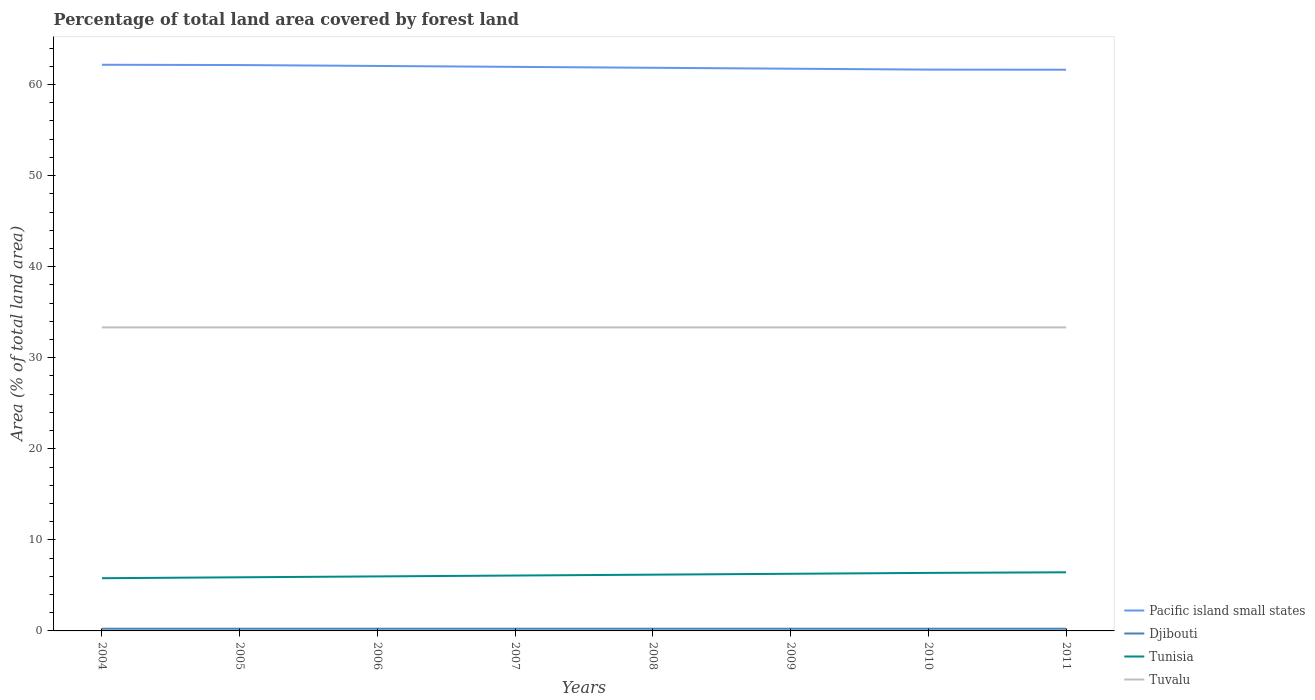How many different coloured lines are there?
Provide a succinct answer. 4. Does the line corresponding to Tuvalu intersect with the line corresponding to Tunisia?
Provide a short and direct response. No. Across all years, what is the maximum percentage of forest land in Tuvalu?
Offer a very short reply. 33.33. In which year was the percentage of forest land in Djibouti maximum?
Keep it short and to the point. 2004. What is the total percentage of forest land in Tunisia in the graph?
Keep it short and to the point. -0.1. What is the difference between the highest and the second highest percentage of forest land in Pacific island small states?
Give a very brief answer. 0.54. What is the difference between the highest and the lowest percentage of forest land in Pacific island small states?
Ensure brevity in your answer.  4. How many lines are there?
Your response must be concise. 4. How many years are there in the graph?
Make the answer very short. 8. Where does the legend appear in the graph?
Offer a very short reply. Bottom right. How many legend labels are there?
Provide a succinct answer. 4. How are the legend labels stacked?
Your answer should be compact. Vertical. What is the title of the graph?
Your response must be concise. Percentage of total land area covered by forest land. Does "East Asia (developing only)" appear as one of the legend labels in the graph?
Provide a short and direct response. No. What is the label or title of the X-axis?
Give a very brief answer. Years. What is the label or title of the Y-axis?
Your response must be concise. Area (% of total land area). What is the Area (% of total land area) in Pacific island small states in 2004?
Offer a terse response. 62.17. What is the Area (% of total land area) of Djibouti in 2004?
Your answer should be compact. 0.24. What is the Area (% of total land area) of Tunisia in 2004?
Ensure brevity in your answer.  5.79. What is the Area (% of total land area) in Tuvalu in 2004?
Offer a very short reply. 33.33. What is the Area (% of total land area) in Pacific island small states in 2005?
Offer a terse response. 62.14. What is the Area (% of total land area) of Djibouti in 2005?
Your answer should be compact. 0.24. What is the Area (% of total land area) of Tunisia in 2005?
Ensure brevity in your answer.  5.89. What is the Area (% of total land area) of Tuvalu in 2005?
Keep it short and to the point. 33.33. What is the Area (% of total land area) of Pacific island small states in 2006?
Your answer should be compact. 62.04. What is the Area (% of total land area) in Djibouti in 2006?
Offer a very short reply. 0.24. What is the Area (% of total land area) in Tunisia in 2006?
Offer a terse response. 5.99. What is the Area (% of total land area) of Tuvalu in 2006?
Keep it short and to the point. 33.33. What is the Area (% of total land area) in Pacific island small states in 2007?
Your answer should be very brief. 61.94. What is the Area (% of total land area) in Djibouti in 2007?
Give a very brief answer. 0.24. What is the Area (% of total land area) of Tunisia in 2007?
Provide a short and direct response. 6.08. What is the Area (% of total land area) in Tuvalu in 2007?
Provide a short and direct response. 33.33. What is the Area (% of total land area) in Pacific island small states in 2008?
Give a very brief answer. 61.84. What is the Area (% of total land area) of Djibouti in 2008?
Provide a short and direct response. 0.24. What is the Area (% of total land area) in Tunisia in 2008?
Your response must be concise. 6.18. What is the Area (% of total land area) in Tuvalu in 2008?
Your response must be concise. 33.33. What is the Area (% of total land area) in Pacific island small states in 2009?
Keep it short and to the point. 61.74. What is the Area (% of total land area) in Djibouti in 2009?
Keep it short and to the point. 0.24. What is the Area (% of total land area) of Tunisia in 2009?
Provide a short and direct response. 6.28. What is the Area (% of total land area) of Tuvalu in 2009?
Your answer should be very brief. 33.33. What is the Area (% of total land area) in Pacific island small states in 2010?
Provide a succinct answer. 61.64. What is the Area (% of total land area) of Djibouti in 2010?
Your response must be concise. 0.24. What is the Area (% of total land area) of Tunisia in 2010?
Keep it short and to the point. 6.37. What is the Area (% of total land area) of Tuvalu in 2010?
Offer a very short reply. 33.33. What is the Area (% of total land area) of Pacific island small states in 2011?
Your answer should be very brief. 61.63. What is the Area (% of total land area) of Djibouti in 2011?
Provide a succinct answer. 0.24. What is the Area (% of total land area) in Tunisia in 2011?
Provide a succinct answer. 6.44. What is the Area (% of total land area) of Tuvalu in 2011?
Your answer should be compact. 33.33. Across all years, what is the maximum Area (% of total land area) of Pacific island small states?
Provide a succinct answer. 62.17. Across all years, what is the maximum Area (% of total land area) in Djibouti?
Your answer should be compact. 0.24. Across all years, what is the maximum Area (% of total land area) of Tunisia?
Your answer should be very brief. 6.44. Across all years, what is the maximum Area (% of total land area) of Tuvalu?
Keep it short and to the point. 33.33. Across all years, what is the minimum Area (% of total land area) in Pacific island small states?
Offer a terse response. 61.63. Across all years, what is the minimum Area (% of total land area) of Djibouti?
Your response must be concise. 0.24. Across all years, what is the minimum Area (% of total land area) of Tunisia?
Offer a very short reply. 5.79. Across all years, what is the minimum Area (% of total land area) of Tuvalu?
Your answer should be very brief. 33.33. What is the total Area (% of total land area) of Pacific island small states in the graph?
Your response must be concise. 495.15. What is the total Area (% of total land area) in Djibouti in the graph?
Your answer should be very brief. 1.93. What is the total Area (% of total land area) in Tunisia in the graph?
Keep it short and to the point. 49.01. What is the total Area (% of total land area) of Tuvalu in the graph?
Your answer should be very brief. 266.67. What is the difference between the Area (% of total land area) in Pacific island small states in 2004 and that in 2005?
Ensure brevity in your answer.  0.03. What is the difference between the Area (% of total land area) of Tunisia in 2004 and that in 2005?
Your response must be concise. -0.1. What is the difference between the Area (% of total land area) in Tuvalu in 2004 and that in 2005?
Provide a short and direct response. 0. What is the difference between the Area (% of total land area) of Pacific island small states in 2004 and that in 2006?
Give a very brief answer. 0.13. What is the difference between the Area (% of total land area) of Djibouti in 2004 and that in 2006?
Keep it short and to the point. 0. What is the difference between the Area (% of total land area) of Tunisia in 2004 and that in 2006?
Your answer should be very brief. -0.2. What is the difference between the Area (% of total land area) of Tuvalu in 2004 and that in 2006?
Give a very brief answer. 0. What is the difference between the Area (% of total land area) of Pacific island small states in 2004 and that in 2007?
Your answer should be very brief. 0.23. What is the difference between the Area (% of total land area) in Tunisia in 2004 and that in 2007?
Offer a terse response. -0.29. What is the difference between the Area (% of total land area) of Pacific island small states in 2004 and that in 2008?
Keep it short and to the point. 0.33. What is the difference between the Area (% of total land area) of Tunisia in 2004 and that in 2008?
Your response must be concise. -0.39. What is the difference between the Area (% of total land area) of Pacific island small states in 2004 and that in 2009?
Provide a short and direct response. 0.43. What is the difference between the Area (% of total land area) of Tunisia in 2004 and that in 2009?
Give a very brief answer. -0.49. What is the difference between the Area (% of total land area) in Tuvalu in 2004 and that in 2009?
Your response must be concise. 0. What is the difference between the Area (% of total land area) in Pacific island small states in 2004 and that in 2010?
Your answer should be compact. 0.53. What is the difference between the Area (% of total land area) of Djibouti in 2004 and that in 2010?
Offer a very short reply. 0. What is the difference between the Area (% of total land area) of Tunisia in 2004 and that in 2010?
Ensure brevity in your answer.  -0.58. What is the difference between the Area (% of total land area) in Pacific island small states in 2004 and that in 2011?
Make the answer very short. 0.54. What is the difference between the Area (% of total land area) in Djibouti in 2004 and that in 2011?
Your answer should be compact. 0. What is the difference between the Area (% of total land area) in Tunisia in 2004 and that in 2011?
Your answer should be compact. -0.65. What is the difference between the Area (% of total land area) of Tuvalu in 2004 and that in 2011?
Provide a short and direct response. 0. What is the difference between the Area (% of total land area) of Pacific island small states in 2005 and that in 2006?
Offer a very short reply. 0.1. What is the difference between the Area (% of total land area) in Djibouti in 2005 and that in 2006?
Ensure brevity in your answer.  0. What is the difference between the Area (% of total land area) of Tunisia in 2005 and that in 2006?
Make the answer very short. -0.1. What is the difference between the Area (% of total land area) in Pacific island small states in 2005 and that in 2007?
Your answer should be compact. 0.2. What is the difference between the Area (% of total land area) of Djibouti in 2005 and that in 2007?
Your answer should be very brief. 0. What is the difference between the Area (% of total land area) of Tunisia in 2005 and that in 2007?
Give a very brief answer. -0.19. What is the difference between the Area (% of total land area) of Tuvalu in 2005 and that in 2007?
Offer a very short reply. 0. What is the difference between the Area (% of total land area) in Pacific island small states in 2005 and that in 2008?
Make the answer very short. 0.3. What is the difference between the Area (% of total land area) in Djibouti in 2005 and that in 2008?
Offer a terse response. 0. What is the difference between the Area (% of total land area) in Tunisia in 2005 and that in 2008?
Give a very brief answer. -0.29. What is the difference between the Area (% of total land area) in Tuvalu in 2005 and that in 2008?
Your answer should be very brief. 0. What is the difference between the Area (% of total land area) in Pacific island small states in 2005 and that in 2009?
Your answer should be very brief. 0.4. What is the difference between the Area (% of total land area) of Djibouti in 2005 and that in 2009?
Offer a terse response. 0. What is the difference between the Area (% of total land area) in Tunisia in 2005 and that in 2009?
Give a very brief answer. -0.39. What is the difference between the Area (% of total land area) in Pacific island small states in 2005 and that in 2010?
Provide a short and direct response. 0.5. What is the difference between the Area (% of total land area) of Tunisia in 2005 and that in 2010?
Keep it short and to the point. -0.48. What is the difference between the Area (% of total land area) in Tuvalu in 2005 and that in 2010?
Your response must be concise. 0. What is the difference between the Area (% of total land area) of Pacific island small states in 2005 and that in 2011?
Your answer should be compact. 0.51. What is the difference between the Area (% of total land area) in Tunisia in 2005 and that in 2011?
Offer a very short reply. -0.55. What is the difference between the Area (% of total land area) of Pacific island small states in 2006 and that in 2007?
Provide a short and direct response. 0.1. What is the difference between the Area (% of total land area) in Tunisia in 2006 and that in 2007?
Keep it short and to the point. -0.1. What is the difference between the Area (% of total land area) of Pacific island small states in 2006 and that in 2008?
Keep it short and to the point. 0.2. What is the difference between the Area (% of total land area) in Djibouti in 2006 and that in 2008?
Provide a short and direct response. 0. What is the difference between the Area (% of total land area) in Tunisia in 2006 and that in 2008?
Make the answer very short. -0.19. What is the difference between the Area (% of total land area) of Pacific island small states in 2006 and that in 2009?
Provide a short and direct response. 0.3. What is the difference between the Area (% of total land area) of Djibouti in 2006 and that in 2009?
Offer a very short reply. 0. What is the difference between the Area (% of total land area) of Tunisia in 2006 and that in 2009?
Make the answer very short. -0.29. What is the difference between the Area (% of total land area) of Tuvalu in 2006 and that in 2009?
Provide a short and direct response. 0. What is the difference between the Area (% of total land area) of Pacific island small states in 2006 and that in 2010?
Ensure brevity in your answer.  0.4. What is the difference between the Area (% of total land area) in Djibouti in 2006 and that in 2010?
Offer a terse response. 0. What is the difference between the Area (% of total land area) in Tunisia in 2006 and that in 2010?
Offer a very short reply. -0.39. What is the difference between the Area (% of total land area) in Pacific island small states in 2006 and that in 2011?
Offer a very short reply. 0.41. What is the difference between the Area (% of total land area) in Djibouti in 2006 and that in 2011?
Provide a short and direct response. 0. What is the difference between the Area (% of total land area) in Tunisia in 2006 and that in 2011?
Provide a short and direct response. -0.45. What is the difference between the Area (% of total land area) in Pacific island small states in 2007 and that in 2008?
Provide a short and direct response. 0.1. What is the difference between the Area (% of total land area) of Djibouti in 2007 and that in 2008?
Make the answer very short. 0. What is the difference between the Area (% of total land area) of Tunisia in 2007 and that in 2008?
Provide a short and direct response. -0.1. What is the difference between the Area (% of total land area) of Tuvalu in 2007 and that in 2008?
Ensure brevity in your answer.  0. What is the difference between the Area (% of total land area) in Pacific island small states in 2007 and that in 2009?
Provide a succinct answer. 0.2. What is the difference between the Area (% of total land area) of Tunisia in 2007 and that in 2009?
Provide a short and direct response. -0.19. What is the difference between the Area (% of total land area) in Tuvalu in 2007 and that in 2009?
Your response must be concise. 0. What is the difference between the Area (% of total land area) of Pacific island small states in 2007 and that in 2010?
Keep it short and to the point. 0.3. What is the difference between the Area (% of total land area) of Djibouti in 2007 and that in 2010?
Your answer should be very brief. 0. What is the difference between the Area (% of total land area) of Tunisia in 2007 and that in 2010?
Your answer should be very brief. -0.29. What is the difference between the Area (% of total land area) of Pacific island small states in 2007 and that in 2011?
Provide a short and direct response. 0.31. What is the difference between the Area (% of total land area) of Djibouti in 2007 and that in 2011?
Make the answer very short. 0. What is the difference between the Area (% of total land area) in Tunisia in 2007 and that in 2011?
Provide a short and direct response. -0.36. What is the difference between the Area (% of total land area) in Pacific island small states in 2008 and that in 2009?
Give a very brief answer. 0.1. What is the difference between the Area (% of total land area) of Tunisia in 2008 and that in 2009?
Give a very brief answer. -0.1. What is the difference between the Area (% of total land area) in Pacific island small states in 2008 and that in 2010?
Provide a succinct answer. 0.2. What is the difference between the Area (% of total land area) of Tunisia in 2008 and that in 2010?
Your answer should be compact. -0.19. What is the difference between the Area (% of total land area) in Pacific island small states in 2008 and that in 2011?
Give a very brief answer. 0.21. What is the difference between the Area (% of total land area) of Tunisia in 2008 and that in 2011?
Make the answer very short. -0.26. What is the difference between the Area (% of total land area) of Tuvalu in 2008 and that in 2011?
Offer a very short reply. 0. What is the difference between the Area (% of total land area) of Pacific island small states in 2009 and that in 2010?
Keep it short and to the point. 0.1. What is the difference between the Area (% of total land area) of Tunisia in 2009 and that in 2010?
Your answer should be compact. -0.1. What is the difference between the Area (% of total land area) in Tuvalu in 2009 and that in 2010?
Your response must be concise. 0. What is the difference between the Area (% of total land area) in Pacific island small states in 2009 and that in 2011?
Give a very brief answer. 0.11. What is the difference between the Area (% of total land area) in Tunisia in 2009 and that in 2011?
Your answer should be compact. -0.16. What is the difference between the Area (% of total land area) in Pacific island small states in 2010 and that in 2011?
Offer a terse response. 0.01. What is the difference between the Area (% of total land area) of Tunisia in 2010 and that in 2011?
Your answer should be very brief. -0.07. What is the difference between the Area (% of total land area) in Tuvalu in 2010 and that in 2011?
Your answer should be compact. 0. What is the difference between the Area (% of total land area) of Pacific island small states in 2004 and the Area (% of total land area) of Djibouti in 2005?
Provide a short and direct response. 61.93. What is the difference between the Area (% of total land area) in Pacific island small states in 2004 and the Area (% of total land area) in Tunisia in 2005?
Offer a terse response. 56.28. What is the difference between the Area (% of total land area) in Pacific island small states in 2004 and the Area (% of total land area) in Tuvalu in 2005?
Keep it short and to the point. 28.84. What is the difference between the Area (% of total land area) of Djibouti in 2004 and the Area (% of total land area) of Tunisia in 2005?
Keep it short and to the point. -5.65. What is the difference between the Area (% of total land area) of Djibouti in 2004 and the Area (% of total land area) of Tuvalu in 2005?
Offer a terse response. -33.09. What is the difference between the Area (% of total land area) of Tunisia in 2004 and the Area (% of total land area) of Tuvalu in 2005?
Offer a terse response. -27.54. What is the difference between the Area (% of total land area) in Pacific island small states in 2004 and the Area (% of total land area) in Djibouti in 2006?
Keep it short and to the point. 61.93. What is the difference between the Area (% of total land area) in Pacific island small states in 2004 and the Area (% of total land area) in Tunisia in 2006?
Your answer should be very brief. 56.19. What is the difference between the Area (% of total land area) of Pacific island small states in 2004 and the Area (% of total land area) of Tuvalu in 2006?
Your response must be concise. 28.84. What is the difference between the Area (% of total land area) in Djibouti in 2004 and the Area (% of total land area) in Tunisia in 2006?
Your answer should be compact. -5.74. What is the difference between the Area (% of total land area) of Djibouti in 2004 and the Area (% of total land area) of Tuvalu in 2006?
Provide a short and direct response. -33.09. What is the difference between the Area (% of total land area) of Tunisia in 2004 and the Area (% of total land area) of Tuvalu in 2006?
Your answer should be compact. -27.54. What is the difference between the Area (% of total land area) of Pacific island small states in 2004 and the Area (% of total land area) of Djibouti in 2007?
Provide a succinct answer. 61.93. What is the difference between the Area (% of total land area) in Pacific island small states in 2004 and the Area (% of total land area) in Tunisia in 2007?
Provide a succinct answer. 56.09. What is the difference between the Area (% of total land area) of Pacific island small states in 2004 and the Area (% of total land area) of Tuvalu in 2007?
Your answer should be very brief. 28.84. What is the difference between the Area (% of total land area) in Djibouti in 2004 and the Area (% of total land area) in Tunisia in 2007?
Offer a very short reply. -5.84. What is the difference between the Area (% of total land area) in Djibouti in 2004 and the Area (% of total land area) in Tuvalu in 2007?
Your answer should be very brief. -33.09. What is the difference between the Area (% of total land area) in Tunisia in 2004 and the Area (% of total land area) in Tuvalu in 2007?
Make the answer very short. -27.54. What is the difference between the Area (% of total land area) in Pacific island small states in 2004 and the Area (% of total land area) in Djibouti in 2008?
Give a very brief answer. 61.93. What is the difference between the Area (% of total land area) in Pacific island small states in 2004 and the Area (% of total land area) in Tunisia in 2008?
Provide a succinct answer. 55.99. What is the difference between the Area (% of total land area) in Pacific island small states in 2004 and the Area (% of total land area) in Tuvalu in 2008?
Give a very brief answer. 28.84. What is the difference between the Area (% of total land area) of Djibouti in 2004 and the Area (% of total land area) of Tunisia in 2008?
Keep it short and to the point. -5.94. What is the difference between the Area (% of total land area) in Djibouti in 2004 and the Area (% of total land area) in Tuvalu in 2008?
Offer a very short reply. -33.09. What is the difference between the Area (% of total land area) in Tunisia in 2004 and the Area (% of total land area) in Tuvalu in 2008?
Keep it short and to the point. -27.54. What is the difference between the Area (% of total land area) of Pacific island small states in 2004 and the Area (% of total land area) of Djibouti in 2009?
Ensure brevity in your answer.  61.93. What is the difference between the Area (% of total land area) in Pacific island small states in 2004 and the Area (% of total land area) in Tunisia in 2009?
Your answer should be very brief. 55.9. What is the difference between the Area (% of total land area) of Pacific island small states in 2004 and the Area (% of total land area) of Tuvalu in 2009?
Ensure brevity in your answer.  28.84. What is the difference between the Area (% of total land area) of Djibouti in 2004 and the Area (% of total land area) of Tunisia in 2009?
Offer a terse response. -6.03. What is the difference between the Area (% of total land area) in Djibouti in 2004 and the Area (% of total land area) in Tuvalu in 2009?
Give a very brief answer. -33.09. What is the difference between the Area (% of total land area) in Tunisia in 2004 and the Area (% of total land area) in Tuvalu in 2009?
Provide a short and direct response. -27.54. What is the difference between the Area (% of total land area) in Pacific island small states in 2004 and the Area (% of total land area) in Djibouti in 2010?
Offer a very short reply. 61.93. What is the difference between the Area (% of total land area) of Pacific island small states in 2004 and the Area (% of total land area) of Tunisia in 2010?
Give a very brief answer. 55.8. What is the difference between the Area (% of total land area) of Pacific island small states in 2004 and the Area (% of total land area) of Tuvalu in 2010?
Offer a terse response. 28.84. What is the difference between the Area (% of total land area) of Djibouti in 2004 and the Area (% of total land area) of Tunisia in 2010?
Your answer should be very brief. -6.13. What is the difference between the Area (% of total land area) of Djibouti in 2004 and the Area (% of total land area) of Tuvalu in 2010?
Ensure brevity in your answer.  -33.09. What is the difference between the Area (% of total land area) of Tunisia in 2004 and the Area (% of total land area) of Tuvalu in 2010?
Your answer should be compact. -27.54. What is the difference between the Area (% of total land area) in Pacific island small states in 2004 and the Area (% of total land area) in Djibouti in 2011?
Offer a very short reply. 61.93. What is the difference between the Area (% of total land area) in Pacific island small states in 2004 and the Area (% of total land area) in Tunisia in 2011?
Your response must be concise. 55.73. What is the difference between the Area (% of total land area) of Pacific island small states in 2004 and the Area (% of total land area) of Tuvalu in 2011?
Your answer should be very brief. 28.84. What is the difference between the Area (% of total land area) of Djibouti in 2004 and the Area (% of total land area) of Tunisia in 2011?
Offer a terse response. -6.2. What is the difference between the Area (% of total land area) of Djibouti in 2004 and the Area (% of total land area) of Tuvalu in 2011?
Ensure brevity in your answer.  -33.09. What is the difference between the Area (% of total land area) of Tunisia in 2004 and the Area (% of total land area) of Tuvalu in 2011?
Your answer should be compact. -27.54. What is the difference between the Area (% of total land area) of Pacific island small states in 2005 and the Area (% of total land area) of Djibouti in 2006?
Your answer should be compact. 61.9. What is the difference between the Area (% of total land area) of Pacific island small states in 2005 and the Area (% of total land area) of Tunisia in 2006?
Provide a short and direct response. 56.16. What is the difference between the Area (% of total land area) of Pacific island small states in 2005 and the Area (% of total land area) of Tuvalu in 2006?
Ensure brevity in your answer.  28.81. What is the difference between the Area (% of total land area) of Djibouti in 2005 and the Area (% of total land area) of Tunisia in 2006?
Your answer should be compact. -5.74. What is the difference between the Area (% of total land area) of Djibouti in 2005 and the Area (% of total land area) of Tuvalu in 2006?
Offer a very short reply. -33.09. What is the difference between the Area (% of total land area) in Tunisia in 2005 and the Area (% of total land area) in Tuvalu in 2006?
Ensure brevity in your answer.  -27.44. What is the difference between the Area (% of total land area) of Pacific island small states in 2005 and the Area (% of total land area) of Djibouti in 2007?
Give a very brief answer. 61.9. What is the difference between the Area (% of total land area) in Pacific island small states in 2005 and the Area (% of total land area) in Tunisia in 2007?
Provide a succinct answer. 56.06. What is the difference between the Area (% of total land area) of Pacific island small states in 2005 and the Area (% of total land area) of Tuvalu in 2007?
Make the answer very short. 28.81. What is the difference between the Area (% of total land area) of Djibouti in 2005 and the Area (% of total land area) of Tunisia in 2007?
Your answer should be compact. -5.84. What is the difference between the Area (% of total land area) of Djibouti in 2005 and the Area (% of total land area) of Tuvalu in 2007?
Provide a succinct answer. -33.09. What is the difference between the Area (% of total land area) of Tunisia in 2005 and the Area (% of total land area) of Tuvalu in 2007?
Keep it short and to the point. -27.44. What is the difference between the Area (% of total land area) in Pacific island small states in 2005 and the Area (% of total land area) in Djibouti in 2008?
Provide a short and direct response. 61.9. What is the difference between the Area (% of total land area) in Pacific island small states in 2005 and the Area (% of total land area) in Tunisia in 2008?
Make the answer very short. 55.96. What is the difference between the Area (% of total land area) in Pacific island small states in 2005 and the Area (% of total land area) in Tuvalu in 2008?
Provide a short and direct response. 28.81. What is the difference between the Area (% of total land area) in Djibouti in 2005 and the Area (% of total land area) in Tunisia in 2008?
Make the answer very short. -5.94. What is the difference between the Area (% of total land area) of Djibouti in 2005 and the Area (% of total land area) of Tuvalu in 2008?
Your response must be concise. -33.09. What is the difference between the Area (% of total land area) in Tunisia in 2005 and the Area (% of total land area) in Tuvalu in 2008?
Keep it short and to the point. -27.44. What is the difference between the Area (% of total land area) of Pacific island small states in 2005 and the Area (% of total land area) of Djibouti in 2009?
Your answer should be very brief. 61.9. What is the difference between the Area (% of total land area) of Pacific island small states in 2005 and the Area (% of total land area) of Tunisia in 2009?
Provide a succinct answer. 55.87. What is the difference between the Area (% of total land area) in Pacific island small states in 2005 and the Area (% of total land area) in Tuvalu in 2009?
Your response must be concise. 28.81. What is the difference between the Area (% of total land area) of Djibouti in 2005 and the Area (% of total land area) of Tunisia in 2009?
Your answer should be very brief. -6.03. What is the difference between the Area (% of total land area) in Djibouti in 2005 and the Area (% of total land area) in Tuvalu in 2009?
Provide a short and direct response. -33.09. What is the difference between the Area (% of total land area) of Tunisia in 2005 and the Area (% of total land area) of Tuvalu in 2009?
Provide a short and direct response. -27.44. What is the difference between the Area (% of total land area) of Pacific island small states in 2005 and the Area (% of total land area) of Djibouti in 2010?
Offer a very short reply. 61.9. What is the difference between the Area (% of total land area) of Pacific island small states in 2005 and the Area (% of total land area) of Tunisia in 2010?
Provide a succinct answer. 55.77. What is the difference between the Area (% of total land area) in Pacific island small states in 2005 and the Area (% of total land area) in Tuvalu in 2010?
Your answer should be very brief. 28.81. What is the difference between the Area (% of total land area) of Djibouti in 2005 and the Area (% of total land area) of Tunisia in 2010?
Offer a very short reply. -6.13. What is the difference between the Area (% of total land area) in Djibouti in 2005 and the Area (% of total land area) in Tuvalu in 2010?
Ensure brevity in your answer.  -33.09. What is the difference between the Area (% of total land area) in Tunisia in 2005 and the Area (% of total land area) in Tuvalu in 2010?
Provide a short and direct response. -27.44. What is the difference between the Area (% of total land area) in Pacific island small states in 2005 and the Area (% of total land area) in Djibouti in 2011?
Your answer should be compact. 61.9. What is the difference between the Area (% of total land area) in Pacific island small states in 2005 and the Area (% of total land area) in Tunisia in 2011?
Provide a short and direct response. 55.71. What is the difference between the Area (% of total land area) of Pacific island small states in 2005 and the Area (% of total land area) of Tuvalu in 2011?
Give a very brief answer. 28.81. What is the difference between the Area (% of total land area) in Djibouti in 2005 and the Area (% of total land area) in Tunisia in 2011?
Your answer should be very brief. -6.2. What is the difference between the Area (% of total land area) in Djibouti in 2005 and the Area (% of total land area) in Tuvalu in 2011?
Make the answer very short. -33.09. What is the difference between the Area (% of total land area) in Tunisia in 2005 and the Area (% of total land area) in Tuvalu in 2011?
Your answer should be very brief. -27.44. What is the difference between the Area (% of total land area) of Pacific island small states in 2006 and the Area (% of total land area) of Djibouti in 2007?
Offer a very short reply. 61.8. What is the difference between the Area (% of total land area) in Pacific island small states in 2006 and the Area (% of total land area) in Tunisia in 2007?
Offer a very short reply. 55.96. What is the difference between the Area (% of total land area) of Pacific island small states in 2006 and the Area (% of total land area) of Tuvalu in 2007?
Keep it short and to the point. 28.71. What is the difference between the Area (% of total land area) of Djibouti in 2006 and the Area (% of total land area) of Tunisia in 2007?
Keep it short and to the point. -5.84. What is the difference between the Area (% of total land area) in Djibouti in 2006 and the Area (% of total land area) in Tuvalu in 2007?
Provide a succinct answer. -33.09. What is the difference between the Area (% of total land area) of Tunisia in 2006 and the Area (% of total land area) of Tuvalu in 2007?
Keep it short and to the point. -27.35. What is the difference between the Area (% of total land area) of Pacific island small states in 2006 and the Area (% of total land area) of Djibouti in 2008?
Provide a succinct answer. 61.8. What is the difference between the Area (% of total land area) of Pacific island small states in 2006 and the Area (% of total land area) of Tunisia in 2008?
Your response must be concise. 55.86. What is the difference between the Area (% of total land area) in Pacific island small states in 2006 and the Area (% of total land area) in Tuvalu in 2008?
Your answer should be very brief. 28.71. What is the difference between the Area (% of total land area) of Djibouti in 2006 and the Area (% of total land area) of Tunisia in 2008?
Keep it short and to the point. -5.94. What is the difference between the Area (% of total land area) of Djibouti in 2006 and the Area (% of total land area) of Tuvalu in 2008?
Give a very brief answer. -33.09. What is the difference between the Area (% of total land area) in Tunisia in 2006 and the Area (% of total land area) in Tuvalu in 2008?
Your answer should be very brief. -27.35. What is the difference between the Area (% of total land area) of Pacific island small states in 2006 and the Area (% of total land area) of Djibouti in 2009?
Provide a succinct answer. 61.8. What is the difference between the Area (% of total land area) of Pacific island small states in 2006 and the Area (% of total land area) of Tunisia in 2009?
Offer a terse response. 55.77. What is the difference between the Area (% of total land area) of Pacific island small states in 2006 and the Area (% of total land area) of Tuvalu in 2009?
Provide a succinct answer. 28.71. What is the difference between the Area (% of total land area) of Djibouti in 2006 and the Area (% of total land area) of Tunisia in 2009?
Your answer should be compact. -6.03. What is the difference between the Area (% of total land area) of Djibouti in 2006 and the Area (% of total land area) of Tuvalu in 2009?
Ensure brevity in your answer.  -33.09. What is the difference between the Area (% of total land area) of Tunisia in 2006 and the Area (% of total land area) of Tuvalu in 2009?
Provide a short and direct response. -27.35. What is the difference between the Area (% of total land area) in Pacific island small states in 2006 and the Area (% of total land area) in Djibouti in 2010?
Keep it short and to the point. 61.8. What is the difference between the Area (% of total land area) in Pacific island small states in 2006 and the Area (% of total land area) in Tunisia in 2010?
Keep it short and to the point. 55.67. What is the difference between the Area (% of total land area) in Pacific island small states in 2006 and the Area (% of total land area) in Tuvalu in 2010?
Your answer should be very brief. 28.71. What is the difference between the Area (% of total land area) of Djibouti in 2006 and the Area (% of total land area) of Tunisia in 2010?
Your response must be concise. -6.13. What is the difference between the Area (% of total land area) in Djibouti in 2006 and the Area (% of total land area) in Tuvalu in 2010?
Your response must be concise. -33.09. What is the difference between the Area (% of total land area) of Tunisia in 2006 and the Area (% of total land area) of Tuvalu in 2010?
Offer a very short reply. -27.35. What is the difference between the Area (% of total land area) in Pacific island small states in 2006 and the Area (% of total land area) in Djibouti in 2011?
Your response must be concise. 61.8. What is the difference between the Area (% of total land area) of Pacific island small states in 2006 and the Area (% of total land area) of Tunisia in 2011?
Give a very brief answer. 55.6. What is the difference between the Area (% of total land area) in Pacific island small states in 2006 and the Area (% of total land area) in Tuvalu in 2011?
Your response must be concise. 28.71. What is the difference between the Area (% of total land area) of Djibouti in 2006 and the Area (% of total land area) of Tunisia in 2011?
Keep it short and to the point. -6.2. What is the difference between the Area (% of total land area) in Djibouti in 2006 and the Area (% of total land area) in Tuvalu in 2011?
Your response must be concise. -33.09. What is the difference between the Area (% of total land area) of Tunisia in 2006 and the Area (% of total land area) of Tuvalu in 2011?
Offer a terse response. -27.35. What is the difference between the Area (% of total land area) in Pacific island small states in 2007 and the Area (% of total land area) in Djibouti in 2008?
Make the answer very short. 61.7. What is the difference between the Area (% of total land area) of Pacific island small states in 2007 and the Area (% of total land area) of Tunisia in 2008?
Make the answer very short. 55.76. What is the difference between the Area (% of total land area) in Pacific island small states in 2007 and the Area (% of total land area) in Tuvalu in 2008?
Ensure brevity in your answer.  28.61. What is the difference between the Area (% of total land area) of Djibouti in 2007 and the Area (% of total land area) of Tunisia in 2008?
Provide a succinct answer. -5.94. What is the difference between the Area (% of total land area) in Djibouti in 2007 and the Area (% of total land area) in Tuvalu in 2008?
Your answer should be compact. -33.09. What is the difference between the Area (% of total land area) of Tunisia in 2007 and the Area (% of total land area) of Tuvalu in 2008?
Keep it short and to the point. -27.25. What is the difference between the Area (% of total land area) of Pacific island small states in 2007 and the Area (% of total land area) of Djibouti in 2009?
Offer a terse response. 61.7. What is the difference between the Area (% of total land area) in Pacific island small states in 2007 and the Area (% of total land area) in Tunisia in 2009?
Give a very brief answer. 55.67. What is the difference between the Area (% of total land area) of Pacific island small states in 2007 and the Area (% of total land area) of Tuvalu in 2009?
Keep it short and to the point. 28.61. What is the difference between the Area (% of total land area) of Djibouti in 2007 and the Area (% of total land area) of Tunisia in 2009?
Ensure brevity in your answer.  -6.03. What is the difference between the Area (% of total land area) in Djibouti in 2007 and the Area (% of total land area) in Tuvalu in 2009?
Offer a very short reply. -33.09. What is the difference between the Area (% of total land area) of Tunisia in 2007 and the Area (% of total land area) of Tuvalu in 2009?
Your response must be concise. -27.25. What is the difference between the Area (% of total land area) in Pacific island small states in 2007 and the Area (% of total land area) in Djibouti in 2010?
Your answer should be compact. 61.7. What is the difference between the Area (% of total land area) in Pacific island small states in 2007 and the Area (% of total land area) in Tunisia in 2010?
Your response must be concise. 55.57. What is the difference between the Area (% of total land area) in Pacific island small states in 2007 and the Area (% of total land area) in Tuvalu in 2010?
Keep it short and to the point. 28.61. What is the difference between the Area (% of total land area) of Djibouti in 2007 and the Area (% of total land area) of Tunisia in 2010?
Provide a short and direct response. -6.13. What is the difference between the Area (% of total land area) of Djibouti in 2007 and the Area (% of total land area) of Tuvalu in 2010?
Provide a succinct answer. -33.09. What is the difference between the Area (% of total land area) of Tunisia in 2007 and the Area (% of total land area) of Tuvalu in 2010?
Your response must be concise. -27.25. What is the difference between the Area (% of total land area) of Pacific island small states in 2007 and the Area (% of total land area) of Djibouti in 2011?
Keep it short and to the point. 61.7. What is the difference between the Area (% of total land area) in Pacific island small states in 2007 and the Area (% of total land area) in Tunisia in 2011?
Provide a short and direct response. 55.5. What is the difference between the Area (% of total land area) in Pacific island small states in 2007 and the Area (% of total land area) in Tuvalu in 2011?
Offer a terse response. 28.61. What is the difference between the Area (% of total land area) in Djibouti in 2007 and the Area (% of total land area) in Tunisia in 2011?
Give a very brief answer. -6.2. What is the difference between the Area (% of total land area) of Djibouti in 2007 and the Area (% of total land area) of Tuvalu in 2011?
Offer a very short reply. -33.09. What is the difference between the Area (% of total land area) of Tunisia in 2007 and the Area (% of total land area) of Tuvalu in 2011?
Ensure brevity in your answer.  -27.25. What is the difference between the Area (% of total land area) of Pacific island small states in 2008 and the Area (% of total land area) of Djibouti in 2009?
Ensure brevity in your answer.  61.6. What is the difference between the Area (% of total land area) of Pacific island small states in 2008 and the Area (% of total land area) of Tunisia in 2009?
Ensure brevity in your answer.  55.57. What is the difference between the Area (% of total land area) in Pacific island small states in 2008 and the Area (% of total land area) in Tuvalu in 2009?
Your response must be concise. 28.51. What is the difference between the Area (% of total land area) of Djibouti in 2008 and the Area (% of total land area) of Tunisia in 2009?
Offer a very short reply. -6.03. What is the difference between the Area (% of total land area) in Djibouti in 2008 and the Area (% of total land area) in Tuvalu in 2009?
Your answer should be compact. -33.09. What is the difference between the Area (% of total land area) in Tunisia in 2008 and the Area (% of total land area) in Tuvalu in 2009?
Provide a short and direct response. -27.15. What is the difference between the Area (% of total land area) of Pacific island small states in 2008 and the Area (% of total land area) of Djibouti in 2010?
Keep it short and to the point. 61.6. What is the difference between the Area (% of total land area) of Pacific island small states in 2008 and the Area (% of total land area) of Tunisia in 2010?
Your answer should be compact. 55.47. What is the difference between the Area (% of total land area) in Pacific island small states in 2008 and the Area (% of total land area) in Tuvalu in 2010?
Your answer should be very brief. 28.51. What is the difference between the Area (% of total land area) of Djibouti in 2008 and the Area (% of total land area) of Tunisia in 2010?
Your response must be concise. -6.13. What is the difference between the Area (% of total land area) in Djibouti in 2008 and the Area (% of total land area) in Tuvalu in 2010?
Your answer should be compact. -33.09. What is the difference between the Area (% of total land area) in Tunisia in 2008 and the Area (% of total land area) in Tuvalu in 2010?
Your response must be concise. -27.15. What is the difference between the Area (% of total land area) of Pacific island small states in 2008 and the Area (% of total land area) of Djibouti in 2011?
Offer a terse response. 61.6. What is the difference between the Area (% of total land area) in Pacific island small states in 2008 and the Area (% of total land area) in Tunisia in 2011?
Keep it short and to the point. 55.4. What is the difference between the Area (% of total land area) of Pacific island small states in 2008 and the Area (% of total land area) of Tuvalu in 2011?
Make the answer very short. 28.51. What is the difference between the Area (% of total land area) of Djibouti in 2008 and the Area (% of total land area) of Tunisia in 2011?
Offer a terse response. -6.2. What is the difference between the Area (% of total land area) of Djibouti in 2008 and the Area (% of total land area) of Tuvalu in 2011?
Ensure brevity in your answer.  -33.09. What is the difference between the Area (% of total land area) of Tunisia in 2008 and the Area (% of total land area) of Tuvalu in 2011?
Provide a succinct answer. -27.15. What is the difference between the Area (% of total land area) of Pacific island small states in 2009 and the Area (% of total land area) of Djibouti in 2010?
Keep it short and to the point. 61.5. What is the difference between the Area (% of total land area) in Pacific island small states in 2009 and the Area (% of total land area) in Tunisia in 2010?
Your answer should be very brief. 55.37. What is the difference between the Area (% of total land area) in Pacific island small states in 2009 and the Area (% of total land area) in Tuvalu in 2010?
Your answer should be very brief. 28.41. What is the difference between the Area (% of total land area) of Djibouti in 2009 and the Area (% of total land area) of Tunisia in 2010?
Offer a very short reply. -6.13. What is the difference between the Area (% of total land area) of Djibouti in 2009 and the Area (% of total land area) of Tuvalu in 2010?
Ensure brevity in your answer.  -33.09. What is the difference between the Area (% of total land area) of Tunisia in 2009 and the Area (% of total land area) of Tuvalu in 2010?
Your response must be concise. -27.06. What is the difference between the Area (% of total land area) in Pacific island small states in 2009 and the Area (% of total land area) in Djibouti in 2011?
Make the answer very short. 61.5. What is the difference between the Area (% of total land area) of Pacific island small states in 2009 and the Area (% of total land area) of Tunisia in 2011?
Offer a very short reply. 55.3. What is the difference between the Area (% of total land area) in Pacific island small states in 2009 and the Area (% of total land area) in Tuvalu in 2011?
Your answer should be very brief. 28.41. What is the difference between the Area (% of total land area) of Djibouti in 2009 and the Area (% of total land area) of Tunisia in 2011?
Your answer should be compact. -6.2. What is the difference between the Area (% of total land area) in Djibouti in 2009 and the Area (% of total land area) in Tuvalu in 2011?
Make the answer very short. -33.09. What is the difference between the Area (% of total land area) in Tunisia in 2009 and the Area (% of total land area) in Tuvalu in 2011?
Your response must be concise. -27.06. What is the difference between the Area (% of total land area) in Pacific island small states in 2010 and the Area (% of total land area) in Djibouti in 2011?
Keep it short and to the point. 61.4. What is the difference between the Area (% of total land area) in Pacific island small states in 2010 and the Area (% of total land area) in Tunisia in 2011?
Your answer should be very brief. 55.2. What is the difference between the Area (% of total land area) in Pacific island small states in 2010 and the Area (% of total land area) in Tuvalu in 2011?
Your answer should be very brief. 28.31. What is the difference between the Area (% of total land area) of Djibouti in 2010 and the Area (% of total land area) of Tunisia in 2011?
Give a very brief answer. -6.2. What is the difference between the Area (% of total land area) of Djibouti in 2010 and the Area (% of total land area) of Tuvalu in 2011?
Offer a terse response. -33.09. What is the difference between the Area (% of total land area) in Tunisia in 2010 and the Area (% of total land area) in Tuvalu in 2011?
Offer a very short reply. -26.96. What is the average Area (% of total land area) of Pacific island small states per year?
Provide a succinct answer. 61.89. What is the average Area (% of total land area) in Djibouti per year?
Your answer should be compact. 0.24. What is the average Area (% of total land area) of Tunisia per year?
Make the answer very short. 6.13. What is the average Area (% of total land area) of Tuvalu per year?
Offer a very short reply. 33.33. In the year 2004, what is the difference between the Area (% of total land area) in Pacific island small states and Area (% of total land area) in Djibouti?
Your answer should be compact. 61.93. In the year 2004, what is the difference between the Area (% of total land area) of Pacific island small states and Area (% of total land area) of Tunisia?
Offer a terse response. 56.38. In the year 2004, what is the difference between the Area (% of total land area) of Pacific island small states and Area (% of total land area) of Tuvalu?
Give a very brief answer. 28.84. In the year 2004, what is the difference between the Area (% of total land area) in Djibouti and Area (% of total land area) in Tunisia?
Offer a terse response. -5.55. In the year 2004, what is the difference between the Area (% of total land area) of Djibouti and Area (% of total land area) of Tuvalu?
Your answer should be compact. -33.09. In the year 2004, what is the difference between the Area (% of total land area) in Tunisia and Area (% of total land area) in Tuvalu?
Your response must be concise. -27.54. In the year 2005, what is the difference between the Area (% of total land area) in Pacific island small states and Area (% of total land area) in Djibouti?
Provide a succinct answer. 61.9. In the year 2005, what is the difference between the Area (% of total land area) in Pacific island small states and Area (% of total land area) in Tunisia?
Your response must be concise. 56.25. In the year 2005, what is the difference between the Area (% of total land area) of Pacific island small states and Area (% of total land area) of Tuvalu?
Provide a short and direct response. 28.81. In the year 2005, what is the difference between the Area (% of total land area) of Djibouti and Area (% of total land area) of Tunisia?
Give a very brief answer. -5.65. In the year 2005, what is the difference between the Area (% of total land area) of Djibouti and Area (% of total land area) of Tuvalu?
Your response must be concise. -33.09. In the year 2005, what is the difference between the Area (% of total land area) in Tunisia and Area (% of total land area) in Tuvalu?
Keep it short and to the point. -27.44. In the year 2006, what is the difference between the Area (% of total land area) in Pacific island small states and Area (% of total land area) in Djibouti?
Provide a short and direct response. 61.8. In the year 2006, what is the difference between the Area (% of total land area) in Pacific island small states and Area (% of total land area) in Tunisia?
Give a very brief answer. 56.06. In the year 2006, what is the difference between the Area (% of total land area) of Pacific island small states and Area (% of total land area) of Tuvalu?
Your answer should be very brief. 28.71. In the year 2006, what is the difference between the Area (% of total land area) in Djibouti and Area (% of total land area) in Tunisia?
Provide a succinct answer. -5.74. In the year 2006, what is the difference between the Area (% of total land area) of Djibouti and Area (% of total land area) of Tuvalu?
Ensure brevity in your answer.  -33.09. In the year 2006, what is the difference between the Area (% of total land area) of Tunisia and Area (% of total land area) of Tuvalu?
Provide a short and direct response. -27.35. In the year 2007, what is the difference between the Area (% of total land area) of Pacific island small states and Area (% of total land area) of Djibouti?
Provide a short and direct response. 61.7. In the year 2007, what is the difference between the Area (% of total land area) in Pacific island small states and Area (% of total land area) in Tunisia?
Give a very brief answer. 55.86. In the year 2007, what is the difference between the Area (% of total land area) of Pacific island small states and Area (% of total land area) of Tuvalu?
Provide a short and direct response. 28.61. In the year 2007, what is the difference between the Area (% of total land area) of Djibouti and Area (% of total land area) of Tunisia?
Offer a terse response. -5.84. In the year 2007, what is the difference between the Area (% of total land area) in Djibouti and Area (% of total land area) in Tuvalu?
Your response must be concise. -33.09. In the year 2007, what is the difference between the Area (% of total land area) of Tunisia and Area (% of total land area) of Tuvalu?
Provide a succinct answer. -27.25. In the year 2008, what is the difference between the Area (% of total land area) in Pacific island small states and Area (% of total land area) in Djibouti?
Ensure brevity in your answer.  61.6. In the year 2008, what is the difference between the Area (% of total land area) of Pacific island small states and Area (% of total land area) of Tunisia?
Offer a very short reply. 55.66. In the year 2008, what is the difference between the Area (% of total land area) of Pacific island small states and Area (% of total land area) of Tuvalu?
Your response must be concise. 28.51. In the year 2008, what is the difference between the Area (% of total land area) in Djibouti and Area (% of total land area) in Tunisia?
Your answer should be very brief. -5.94. In the year 2008, what is the difference between the Area (% of total land area) of Djibouti and Area (% of total land area) of Tuvalu?
Your response must be concise. -33.09. In the year 2008, what is the difference between the Area (% of total land area) of Tunisia and Area (% of total land area) of Tuvalu?
Offer a very short reply. -27.15. In the year 2009, what is the difference between the Area (% of total land area) in Pacific island small states and Area (% of total land area) in Djibouti?
Offer a very short reply. 61.5. In the year 2009, what is the difference between the Area (% of total land area) in Pacific island small states and Area (% of total land area) in Tunisia?
Make the answer very short. 55.47. In the year 2009, what is the difference between the Area (% of total land area) of Pacific island small states and Area (% of total land area) of Tuvalu?
Provide a short and direct response. 28.41. In the year 2009, what is the difference between the Area (% of total land area) of Djibouti and Area (% of total land area) of Tunisia?
Keep it short and to the point. -6.03. In the year 2009, what is the difference between the Area (% of total land area) in Djibouti and Area (% of total land area) in Tuvalu?
Offer a terse response. -33.09. In the year 2009, what is the difference between the Area (% of total land area) in Tunisia and Area (% of total land area) in Tuvalu?
Your response must be concise. -27.06. In the year 2010, what is the difference between the Area (% of total land area) of Pacific island small states and Area (% of total land area) of Djibouti?
Make the answer very short. 61.4. In the year 2010, what is the difference between the Area (% of total land area) in Pacific island small states and Area (% of total land area) in Tunisia?
Your response must be concise. 55.27. In the year 2010, what is the difference between the Area (% of total land area) of Pacific island small states and Area (% of total land area) of Tuvalu?
Offer a terse response. 28.31. In the year 2010, what is the difference between the Area (% of total land area) of Djibouti and Area (% of total land area) of Tunisia?
Offer a very short reply. -6.13. In the year 2010, what is the difference between the Area (% of total land area) of Djibouti and Area (% of total land area) of Tuvalu?
Offer a terse response. -33.09. In the year 2010, what is the difference between the Area (% of total land area) in Tunisia and Area (% of total land area) in Tuvalu?
Your answer should be very brief. -26.96. In the year 2011, what is the difference between the Area (% of total land area) in Pacific island small states and Area (% of total land area) in Djibouti?
Provide a short and direct response. 61.39. In the year 2011, what is the difference between the Area (% of total land area) in Pacific island small states and Area (% of total land area) in Tunisia?
Provide a succinct answer. 55.19. In the year 2011, what is the difference between the Area (% of total land area) of Pacific island small states and Area (% of total land area) of Tuvalu?
Provide a succinct answer. 28.3. In the year 2011, what is the difference between the Area (% of total land area) in Djibouti and Area (% of total land area) in Tunisia?
Give a very brief answer. -6.2. In the year 2011, what is the difference between the Area (% of total land area) of Djibouti and Area (% of total land area) of Tuvalu?
Offer a terse response. -33.09. In the year 2011, what is the difference between the Area (% of total land area) of Tunisia and Area (% of total land area) of Tuvalu?
Your response must be concise. -26.9. What is the ratio of the Area (% of total land area) in Tunisia in 2004 to that in 2005?
Give a very brief answer. 0.98. What is the ratio of the Area (% of total land area) of Pacific island small states in 2004 to that in 2006?
Provide a succinct answer. 1. What is the ratio of the Area (% of total land area) in Tunisia in 2004 to that in 2006?
Give a very brief answer. 0.97. What is the ratio of the Area (% of total land area) in Djibouti in 2004 to that in 2007?
Offer a very short reply. 1. What is the ratio of the Area (% of total land area) in Tunisia in 2004 to that in 2007?
Keep it short and to the point. 0.95. What is the ratio of the Area (% of total land area) in Tunisia in 2004 to that in 2008?
Provide a short and direct response. 0.94. What is the ratio of the Area (% of total land area) in Tuvalu in 2004 to that in 2008?
Give a very brief answer. 1. What is the ratio of the Area (% of total land area) in Djibouti in 2004 to that in 2009?
Provide a succinct answer. 1. What is the ratio of the Area (% of total land area) of Tunisia in 2004 to that in 2009?
Provide a short and direct response. 0.92. What is the ratio of the Area (% of total land area) of Tuvalu in 2004 to that in 2009?
Give a very brief answer. 1. What is the ratio of the Area (% of total land area) in Pacific island small states in 2004 to that in 2010?
Keep it short and to the point. 1.01. What is the ratio of the Area (% of total land area) of Djibouti in 2004 to that in 2010?
Your response must be concise. 1. What is the ratio of the Area (% of total land area) in Tunisia in 2004 to that in 2010?
Make the answer very short. 0.91. What is the ratio of the Area (% of total land area) of Pacific island small states in 2004 to that in 2011?
Your answer should be very brief. 1.01. What is the ratio of the Area (% of total land area) of Tunisia in 2004 to that in 2011?
Ensure brevity in your answer.  0.9. What is the ratio of the Area (% of total land area) of Djibouti in 2005 to that in 2006?
Provide a short and direct response. 1. What is the ratio of the Area (% of total land area) of Tunisia in 2005 to that in 2006?
Make the answer very short. 0.98. What is the ratio of the Area (% of total land area) of Pacific island small states in 2005 to that in 2007?
Provide a succinct answer. 1. What is the ratio of the Area (% of total land area) in Djibouti in 2005 to that in 2007?
Your answer should be compact. 1. What is the ratio of the Area (% of total land area) in Tunisia in 2005 to that in 2007?
Provide a succinct answer. 0.97. What is the ratio of the Area (% of total land area) of Tuvalu in 2005 to that in 2007?
Ensure brevity in your answer.  1. What is the ratio of the Area (% of total land area) of Tunisia in 2005 to that in 2008?
Your response must be concise. 0.95. What is the ratio of the Area (% of total land area) in Tunisia in 2005 to that in 2009?
Provide a succinct answer. 0.94. What is the ratio of the Area (% of total land area) in Tuvalu in 2005 to that in 2009?
Offer a very short reply. 1. What is the ratio of the Area (% of total land area) in Pacific island small states in 2005 to that in 2010?
Offer a terse response. 1.01. What is the ratio of the Area (% of total land area) of Tunisia in 2005 to that in 2010?
Your answer should be very brief. 0.92. What is the ratio of the Area (% of total land area) in Pacific island small states in 2005 to that in 2011?
Your answer should be very brief. 1.01. What is the ratio of the Area (% of total land area) of Tunisia in 2005 to that in 2011?
Make the answer very short. 0.91. What is the ratio of the Area (% of total land area) in Pacific island small states in 2006 to that in 2007?
Offer a terse response. 1. What is the ratio of the Area (% of total land area) of Djibouti in 2006 to that in 2007?
Offer a terse response. 1. What is the ratio of the Area (% of total land area) of Tunisia in 2006 to that in 2007?
Offer a very short reply. 0.98. What is the ratio of the Area (% of total land area) of Tuvalu in 2006 to that in 2007?
Offer a very short reply. 1. What is the ratio of the Area (% of total land area) of Tunisia in 2006 to that in 2008?
Give a very brief answer. 0.97. What is the ratio of the Area (% of total land area) of Pacific island small states in 2006 to that in 2009?
Provide a succinct answer. 1. What is the ratio of the Area (% of total land area) in Djibouti in 2006 to that in 2009?
Provide a succinct answer. 1. What is the ratio of the Area (% of total land area) of Tunisia in 2006 to that in 2009?
Offer a very short reply. 0.95. What is the ratio of the Area (% of total land area) of Tunisia in 2006 to that in 2010?
Ensure brevity in your answer.  0.94. What is the ratio of the Area (% of total land area) of Tuvalu in 2006 to that in 2010?
Offer a terse response. 1. What is the ratio of the Area (% of total land area) in Pacific island small states in 2006 to that in 2011?
Your response must be concise. 1.01. What is the ratio of the Area (% of total land area) of Tunisia in 2006 to that in 2011?
Your answer should be compact. 0.93. What is the ratio of the Area (% of total land area) in Djibouti in 2007 to that in 2008?
Provide a short and direct response. 1. What is the ratio of the Area (% of total land area) of Tunisia in 2007 to that in 2008?
Give a very brief answer. 0.98. What is the ratio of the Area (% of total land area) in Pacific island small states in 2007 to that in 2009?
Offer a terse response. 1. What is the ratio of the Area (% of total land area) of Tunisia in 2007 to that in 2009?
Your response must be concise. 0.97. What is the ratio of the Area (% of total land area) in Pacific island small states in 2007 to that in 2010?
Offer a very short reply. 1. What is the ratio of the Area (% of total land area) in Djibouti in 2007 to that in 2010?
Offer a terse response. 1. What is the ratio of the Area (% of total land area) in Tunisia in 2007 to that in 2010?
Make the answer very short. 0.95. What is the ratio of the Area (% of total land area) in Pacific island small states in 2007 to that in 2011?
Give a very brief answer. 1.01. What is the ratio of the Area (% of total land area) of Djibouti in 2007 to that in 2011?
Offer a very short reply. 1. What is the ratio of the Area (% of total land area) in Tunisia in 2007 to that in 2011?
Provide a short and direct response. 0.94. What is the ratio of the Area (% of total land area) of Pacific island small states in 2008 to that in 2009?
Make the answer very short. 1. What is the ratio of the Area (% of total land area) of Tunisia in 2008 to that in 2009?
Your answer should be very brief. 0.98. What is the ratio of the Area (% of total land area) of Tuvalu in 2008 to that in 2009?
Offer a terse response. 1. What is the ratio of the Area (% of total land area) of Tunisia in 2008 to that in 2010?
Offer a very short reply. 0.97. What is the ratio of the Area (% of total land area) in Djibouti in 2008 to that in 2011?
Give a very brief answer. 1. What is the ratio of the Area (% of total land area) of Tunisia in 2008 to that in 2011?
Offer a very short reply. 0.96. What is the ratio of the Area (% of total land area) in Pacific island small states in 2009 to that in 2010?
Your answer should be compact. 1. What is the ratio of the Area (% of total land area) in Djibouti in 2009 to that in 2010?
Offer a terse response. 1. What is the ratio of the Area (% of total land area) of Tuvalu in 2009 to that in 2010?
Your answer should be compact. 1. What is the ratio of the Area (% of total land area) in Djibouti in 2009 to that in 2011?
Offer a terse response. 1. What is the ratio of the Area (% of total land area) of Tunisia in 2009 to that in 2011?
Your response must be concise. 0.97. What is the ratio of the Area (% of total land area) in Tuvalu in 2009 to that in 2011?
Your answer should be compact. 1. What is the ratio of the Area (% of total land area) of Pacific island small states in 2010 to that in 2011?
Make the answer very short. 1. What is the ratio of the Area (% of total land area) of Djibouti in 2010 to that in 2011?
Offer a very short reply. 1. What is the ratio of the Area (% of total land area) in Tunisia in 2010 to that in 2011?
Ensure brevity in your answer.  0.99. What is the difference between the highest and the second highest Area (% of total land area) of Pacific island small states?
Your answer should be compact. 0.03. What is the difference between the highest and the second highest Area (% of total land area) in Tunisia?
Keep it short and to the point. 0.07. What is the difference between the highest and the second highest Area (% of total land area) of Tuvalu?
Give a very brief answer. 0. What is the difference between the highest and the lowest Area (% of total land area) in Pacific island small states?
Ensure brevity in your answer.  0.54. What is the difference between the highest and the lowest Area (% of total land area) in Djibouti?
Your answer should be very brief. 0. What is the difference between the highest and the lowest Area (% of total land area) in Tunisia?
Provide a short and direct response. 0.65. 